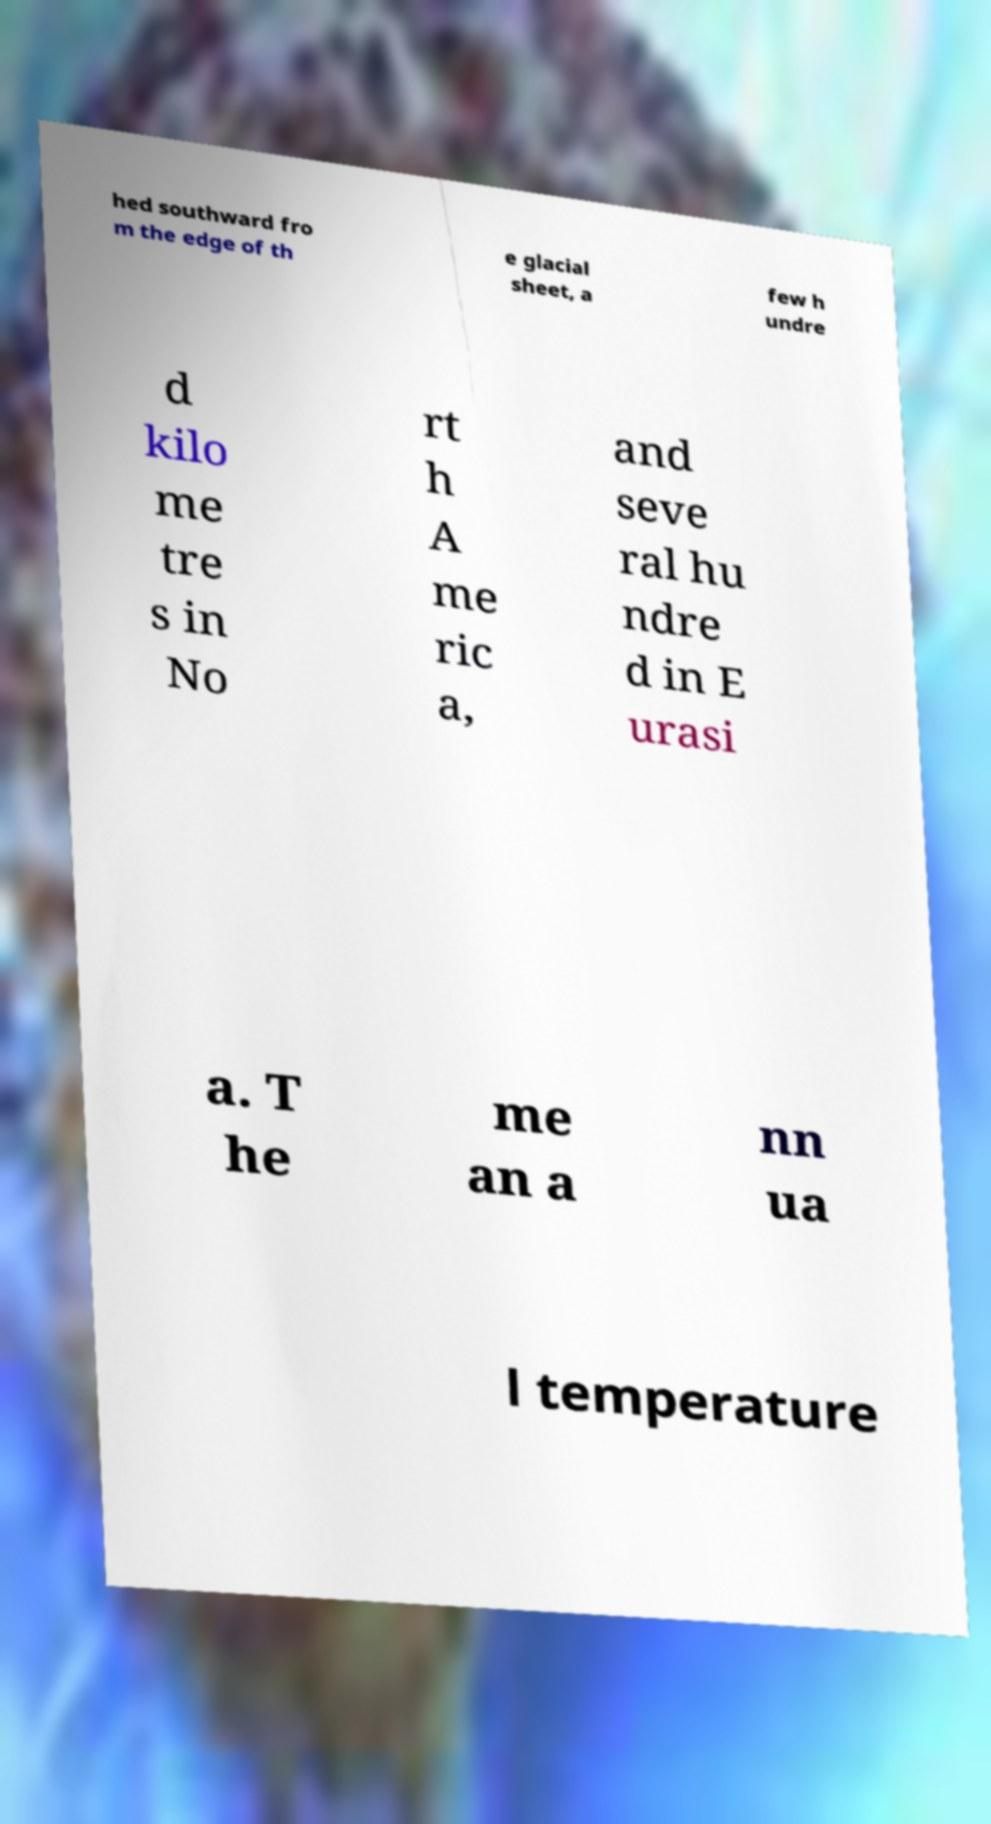Please read and relay the text visible in this image. What does it say? hed southward fro m the edge of th e glacial sheet, a few h undre d kilo me tre s in No rt h A me ric a, and seve ral hu ndre d in E urasi a. T he me an a nn ua l temperature 